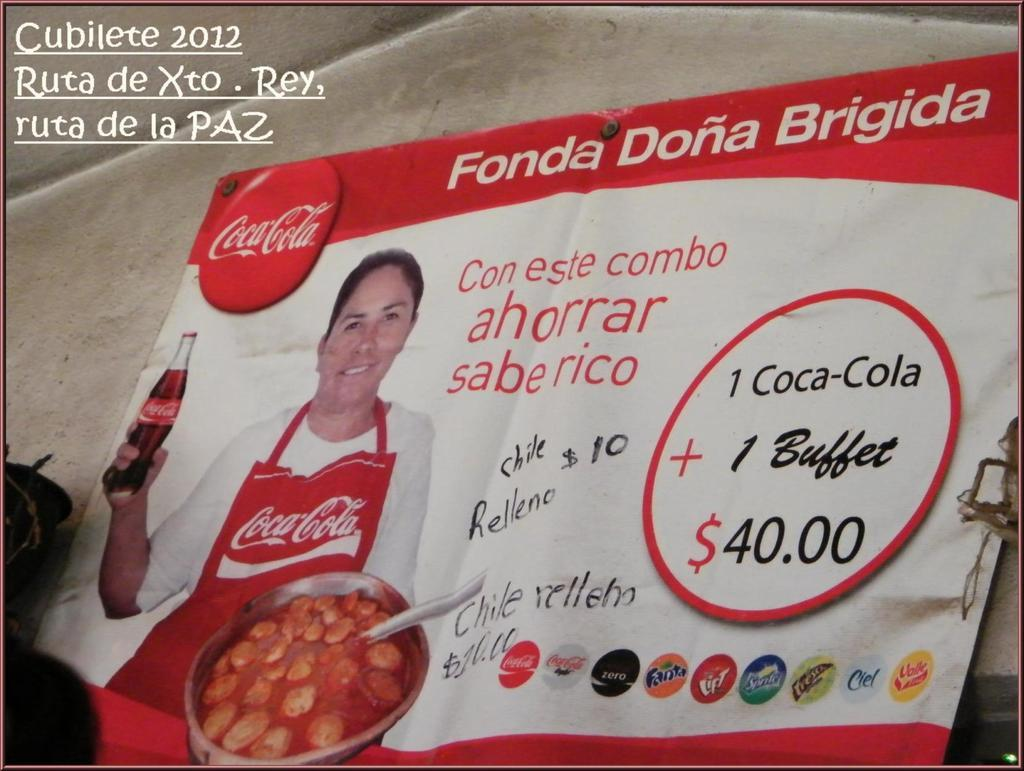What is the main subject of the poster in the image? The poster features a woman holding a coke. What else can be seen on the poster besides the woman and the coke? There is text on the poster. What is visible in the background of the image? There is a wall in the background of the image. Can you see any flames coming from the coke in the image? No, there are no flames present in the image. 